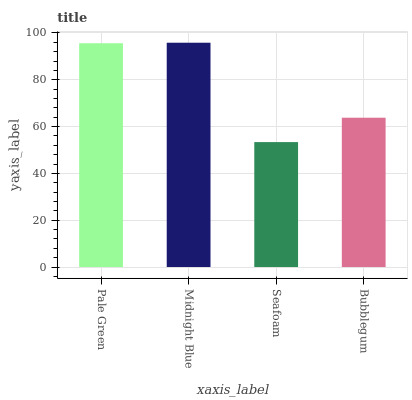Is Seafoam the minimum?
Answer yes or no. Yes. Is Midnight Blue the maximum?
Answer yes or no. Yes. Is Midnight Blue the minimum?
Answer yes or no. No. Is Seafoam the maximum?
Answer yes or no. No. Is Midnight Blue greater than Seafoam?
Answer yes or no. Yes. Is Seafoam less than Midnight Blue?
Answer yes or no. Yes. Is Seafoam greater than Midnight Blue?
Answer yes or no. No. Is Midnight Blue less than Seafoam?
Answer yes or no. No. Is Pale Green the high median?
Answer yes or no. Yes. Is Bubblegum the low median?
Answer yes or no. Yes. Is Seafoam the high median?
Answer yes or no. No. Is Pale Green the low median?
Answer yes or no. No. 